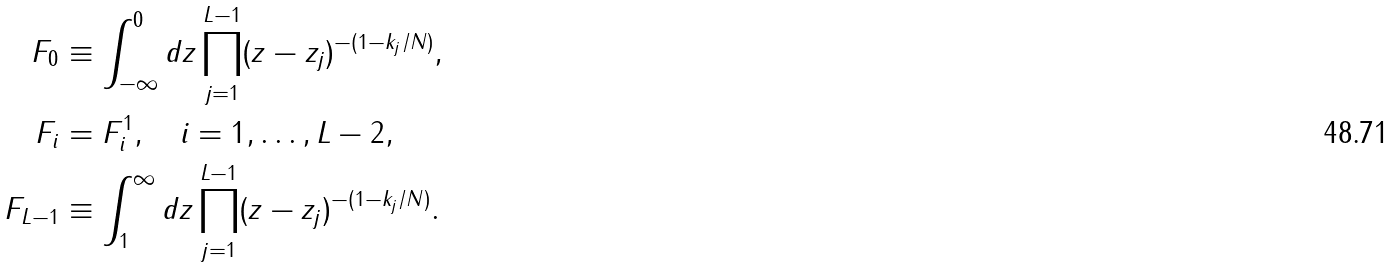Convert formula to latex. <formula><loc_0><loc_0><loc_500><loc_500>F _ { 0 } & \equiv \int _ { - \infty } ^ { 0 } d z \prod _ { j = 1 } ^ { L - 1 } ( z - z _ { j } ) ^ { - ( 1 - k _ { j } / N ) } , \\ F _ { i } & = F _ { i } ^ { 1 } , \quad i = 1 , \dots , L - 2 , \\ F _ { L - 1 } & \equiv \int _ { 1 } ^ { \infty } d z \prod _ { j = 1 } ^ { L - 1 } ( z - z _ { j } ) ^ { - ( 1 - k _ { j } / N ) } .</formula> 